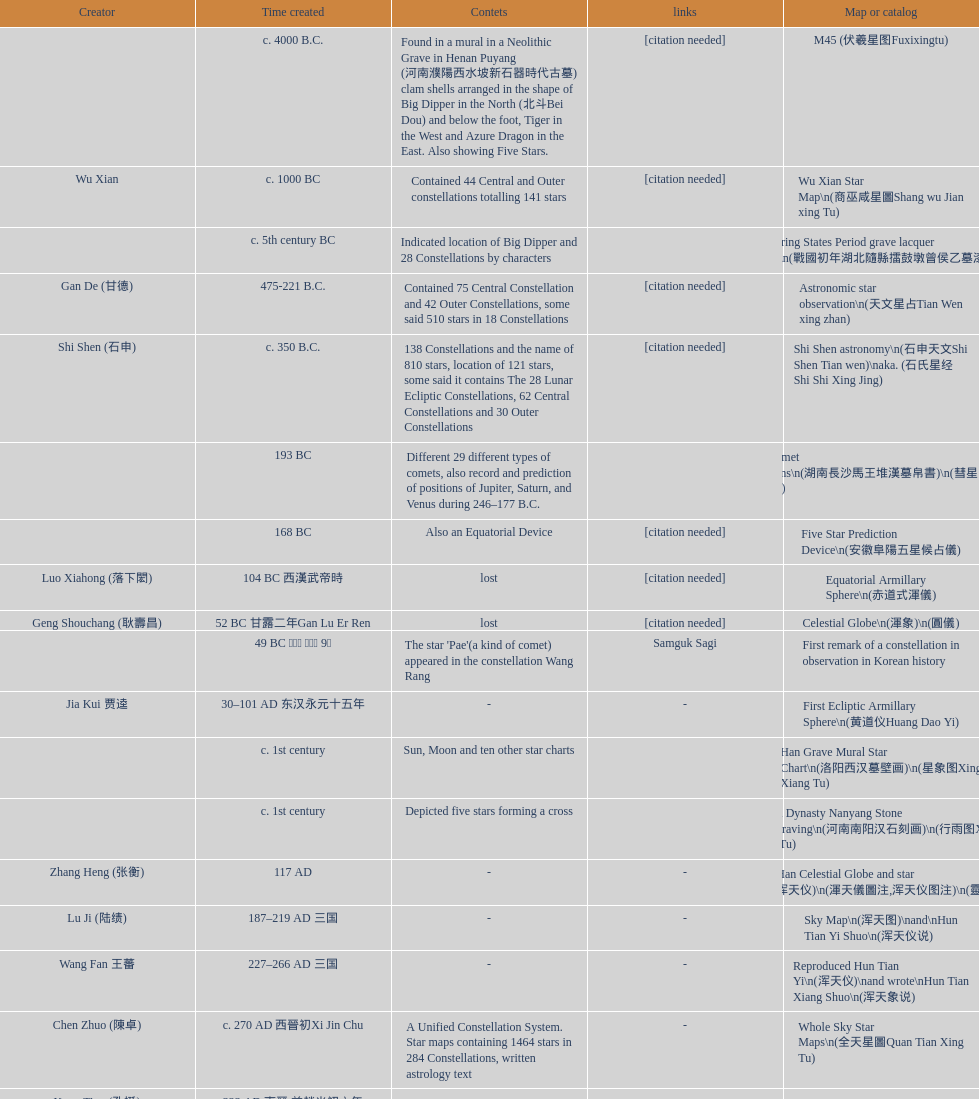Did xu guang ci or su song create the five star charts in 1094 ad? Su Song 蘇頌. 